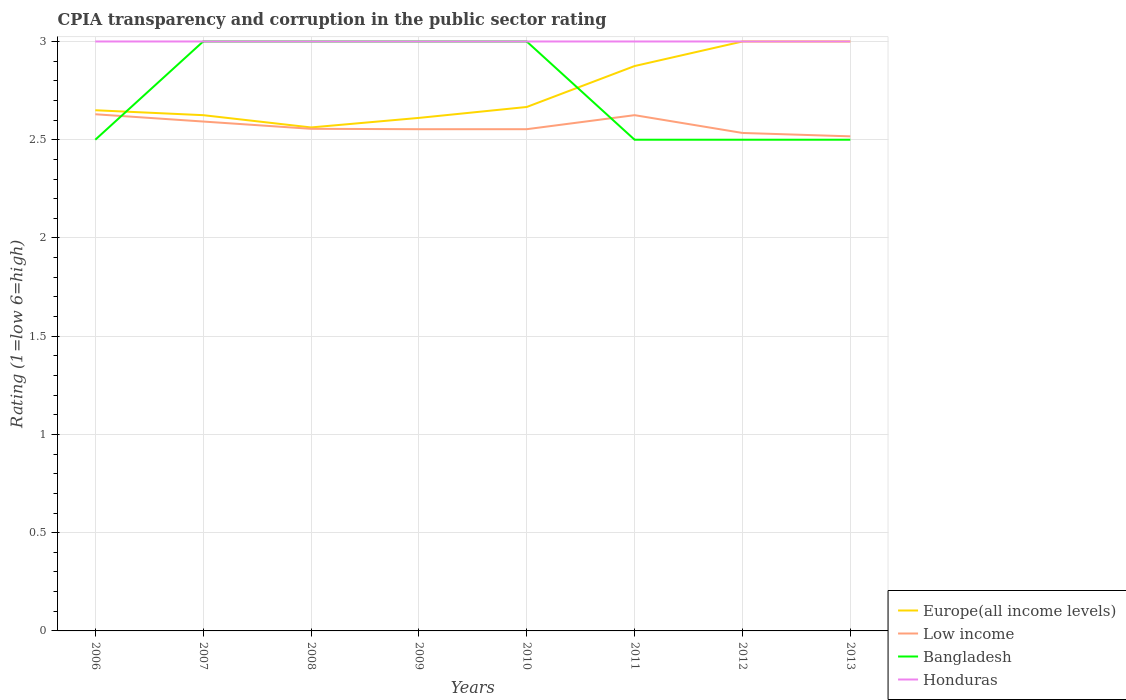How many different coloured lines are there?
Provide a succinct answer. 4. Is the number of lines equal to the number of legend labels?
Offer a terse response. Yes. Across all years, what is the maximum CPIA rating in Honduras?
Offer a terse response. 3. In which year was the CPIA rating in Low income maximum?
Give a very brief answer. 2013. What is the total CPIA rating in Bangladesh in the graph?
Ensure brevity in your answer.  0.5. What is the difference between the highest and the second highest CPIA rating in Low income?
Offer a very short reply. 0.11. What is the difference between the highest and the lowest CPIA rating in Bangladesh?
Offer a terse response. 4. Is the CPIA rating in Low income strictly greater than the CPIA rating in Honduras over the years?
Provide a short and direct response. Yes. How many years are there in the graph?
Ensure brevity in your answer.  8. What is the difference between two consecutive major ticks on the Y-axis?
Offer a terse response. 0.5. Does the graph contain any zero values?
Offer a terse response. No. Does the graph contain grids?
Make the answer very short. Yes. Where does the legend appear in the graph?
Your answer should be very brief. Bottom right. What is the title of the graph?
Your response must be concise. CPIA transparency and corruption in the public sector rating. Does "Uganda" appear as one of the legend labels in the graph?
Your answer should be compact. No. What is the Rating (1=low 6=high) in Europe(all income levels) in 2006?
Your response must be concise. 2.65. What is the Rating (1=low 6=high) of Low income in 2006?
Give a very brief answer. 2.63. What is the Rating (1=low 6=high) of Europe(all income levels) in 2007?
Ensure brevity in your answer.  2.62. What is the Rating (1=low 6=high) of Low income in 2007?
Your answer should be compact. 2.59. What is the Rating (1=low 6=high) in Bangladesh in 2007?
Make the answer very short. 3. What is the Rating (1=low 6=high) in Europe(all income levels) in 2008?
Ensure brevity in your answer.  2.56. What is the Rating (1=low 6=high) of Low income in 2008?
Keep it short and to the point. 2.56. What is the Rating (1=low 6=high) of Bangladesh in 2008?
Offer a very short reply. 3. What is the Rating (1=low 6=high) in Honduras in 2008?
Provide a succinct answer. 3. What is the Rating (1=low 6=high) in Europe(all income levels) in 2009?
Offer a terse response. 2.61. What is the Rating (1=low 6=high) of Low income in 2009?
Ensure brevity in your answer.  2.55. What is the Rating (1=low 6=high) in Bangladesh in 2009?
Ensure brevity in your answer.  3. What is the Rating (1=low 6=high) in Honduras in 2009?
Offer a very short reply. 3. What is the Rating (1=low 6=high) of Europe(all income levels) in 2010?
Your answer should be compact. 2.67. What is the Rating (1=low 6=high) of Low income in 2010?
Give a very brief answer. 2.55. What is the Rating (1=low 6=high) in Europe(all income levels) in 2011?
Ensure brevity in your answer.  2.88. What is the Rating (1=low 6=high) in Low income in 2011?
Give a very brief answer. 2.62. What is the Rating (1=low 6=high) in Bangladesh in 2011?
Your answer should be very brief. 2.5. What is the Rating (1=low 6=high) of Honduras in 2011?
Provide a short and direct response. 3. What is the Rating (1=low 6=high) of Europe(all income levels) in 2012?
Offer a very short reply. 3. What is the Rating (1=low 6=high) in Low income in 2012?
Keep it short and to the point. 2.53. What is the Rating (1=low 6=high) of Bangladesh in 2012?
Your response must be concise. 2.5. What is the Rating (1=low 6=high) of Europe(all income levels) in 2013?
Your response must be concise. 3. What is the Rating (1=low 6=high) of Low income in 2013?
Provide a short and direct response. 2.52. What is the Rating (1=low 6=high) in Honduras in 2013?
Offer a terse response. 3. Across all years, what is the maximum Rating (1=low 6=high) of Europe(all income levels)?
Offer a very short reply. 3. Across all years, what is the maximum Rating (1=low 6=high) of Low income?
Your response must be concise. 2.63. Across all years, what is the maximum Rating (1=low 6=high) in Honduras?
Offer a terse response. 3. Across all years, what is the minimum Rating (1=low 6=high) of Europe(all income levels)?
Keep it short and to the point. 2.56. Across all years, what is the minimum Rating (1=low 6=high) in Low income?
Give a very brief answer. 2.52. Across all years, what is the minimum Rating (1=low 6=high) in Bangladesh?
Offer a terse response. 2.5. What is the total Rating (1=low 6=high) of Europe(all income levels) in the graph?
Ensure brevity in your answer.  21.99. What is the total Rating (1=low 6=high) in Low income in the graph?
Keep it short and to the point. 20.56. What is the difference between the Rating (1=low 6=high) of Europe(all income levels) in 2006 and that in 2007?
Your response must be concise. 0.03. What is the difference between the Rating (1=low 6=high) in Low income in 2006 and that in 2007?
Offer a terse response. 0.04. What is the difference between the Rating (1=low 6=high) of Bangladesh in 2006 and that in 2007?
Make the answer very short. -0.5. What is the difference between the Rating (1=low 6=high) in Honduras in 2006 and that in 2007?
Keep it short and to the point. 0. What is the difference between the Rating (1=low 6=high) in Europe(all income levels) in 2006 and that in 2008?
Keep it short and to the point. 0.09. What is the difference between the Rating (1=low 6=high) in Low income in 2006 and that in 2008?
Your answer should be very brief. 0.07. What is the difference between the Rating (1=low 6=high) of Honduras in 2006 and that in 2008?
Make the answer very short. 0. What is the difference between the Rating (1=low 6=high) in Europe(all income levels) in 2006 and that in 2009?
Keep it short and to the point. 0.04. What is the difference between the Rating (1=low 6=high) in Low income in 2006 and that in 2009?
Make the answer very short. 0.08. What is the difference between the Rating (1=low 6=high) in Honduras in 2006 and that in 2009?
Provide a short and direct response. 0. What is the difference between the Rating (1=low 6=high) in Europe(all income levels) in 2006 and that in 2010?
Offer a terse response. -0.02. What is the difference between the Rating (1=low 6=high) of Low income in 2006 and that in 2010?
Offer a terse response. 0.08. What is the difference between the Rating (1=low 6=high) of Honduras in 2006 and that in 2010?
Provide a succinct answer. 0. What is the difference between the Rating (1=low 6=high) in Europe(all income levels) in 2006 and that in 2011?
Make the answer very short. -0.23. What is the difference between the Rating (1=low 6=high) in Low income in 2006 and that in 2011?
Provide a short and direct response. 0. What is the difference between the Rating (1=low 6=high) in Bangladesh in 2006 and that in 2011?
Give a very brief answer. 0. What is the difference between the Rating (1=low 6=high) of Europe(all income levels) in 2006 and that in 2012?
Give a very brief answer. -0.35. What is the difference between the Rating (1=low 6=high) of Low income in 2006 and that in 2012?
Provide a succinct answer. 0.1. What is the difference between the Rating (1=low 6=high) in Europe(all income levels) in 2006 and that in 2013?
Offer a very short reply. -0.35. What is the difference between the Rating (1=low 6=high) in Low income in 2006 and that in 2013?
Make the answer very short. 0.11. What is the difference between the Rating (1=low 6=high) in Bangladesh in 2006 and that in 2013?
Ensure brevity in your answer.  0. What is the difference between the Rating (1=low 6=high) of Europe(all income levels) in 2007 and that in 2008?
Ensure brevity in your answer.  0.06. What is the difference between the Rating (1=low 6=high) in Low income in 2007 and that in 2008?
Give a very brief answer. 0.04. What is the difference between the Rating (1=low 6=high) of Europe(all income levels) in 2007 and that in 2009?
Make the answer very short. 0.01. What is the difference between the Rating (1=low 6=high) of Low income in 2007 and that in 2009?
Offer a terse response. 0.04. What is the difference between the Rating (1=low 6=high) of Europe(all income levels) in 2007 and that in 2010?
Offer a terse response. -0.04. What is the difference between the Rating (1=low 6=high) in Low income in 2007 and that in 2010?
Your answer should be compact. 0.04. What is the difference between the Rating (1=low 6=high) in Bangladesh in 2007 and that in 2010?
Offer a terse response. 0. What is the difference between the Rating (1=low 6=high) in Europe(all income levels) in 2007 and that in 2011?
Ensure brevity in your answer.  -0.25. What is the difference between the Rating (1=low 6=high) of Low income in 2007 and that in 2011?
Your response must be concise. -0.03. What is the difference between the Rating (1=low 6=high) of Honduras in 2007 and that in 2011?
Provide a short and direct response. 0. What is the difference between the Rating (1=low 6=high) in Europe(all income levels) in 2007 and that in 2012?
Provide a succinct answer. -0.38. What is the difference between the Rating (1=low 6=high) of Low income in 2007 and that in 2012?
Make the answer very short. 0.06. What is the difference between the Rating (1=low 6=high) in Europe(all income levels) in 2007 and that in 2013?
Your response must be concise. -0.38. What is the difference between the Rating (1=low 6=high) in Low income in 2007 and that in 2013?
Offer a very short reply. 0.08. What is the difference between the Rating (1=low 6=high) of Honduras in 2007 and that in 2013?
Give a very brief answer. 0. What is the difference between the Rating (1=low 6=high) of Europe(all income levels) in 2008 and that in 2009?
Your answer should be very brief. -0.05. What is the difference between the Rating (1=low 6=high) of Low income in 2008 and that in 2009?
Your answer should be very brief. 0. What is the difference between the Rating (1=low 6=high) of Bangladesh in 2008 and that in 2009?
Your answer should be compact. 0. What is the difference between the Rating (1=low 6=high) in Europe(all income levels) in 2008 and that in 2010?
Your response must be concise. -0.1. What is the difference between the Rating (1=low 6=high) in Low income in 2008 and that in 2010?
Provide a short and direct response. 0. What is the difference between the Rating (1=low 6=high) in Honduras in 2008 and that in 2010?
Provide a succinct answer. 0. What is the difference between the Rating (1=low 6=high) in Europe(all income levels) in 2008 and that in 2011?
Offer a very short reply. -0.31. What is the difference between the Rating (1=low 6=high) of Low income in 2008 and that in 2011?
Offer a terse response. -0.07. What is the difference between the Rating (1=low 6=high) of Honduras in 2008 and that in 2011?
Your answer should be very brief. 0. What is the difference between the Rating (1=low 6=high) in Europe(all income levels) in 2008 and that in 2012?
Your response must be concise. -0.44. What is the difference between the Rating (1=low 6=high) of Low income in 2008 and that in 2012?
Your answer should be very brief. 0.02. What is the difference between the Rating (1=low 6=high) in Bangladesh in 2008 and that in 2012?
Keep it short and to the point. 0.5. What is the difference between the Rating (1=low 6=high) of Europe(all income levels) in 2008 and that in 2013?
Offer a terse response. -0.44. What is the difference between the Rating (1=low 6=high) of Low income in 2008 and that in 2013?
Your answer should be compact. 0.04. What is the difference between the Rating (1=low 6=high) of Bangladesh in 2008 and that in 2013?
Your answer should be very brief. 0.5. What is the difference between the Rating (1=low 6=high) of Honduras in 2008 and that in 2013?
Keep it short and to the point. 0. What is the difference between the Rating (1=low 6=high) of Europe(all income levels) in 2009 and that in 2010?
Provide a short and direct response. -0.06. What is the difference between the Rating (1=low 6=high) of Low income in 2009 and that in 2010?
Offer a terse response. 0. What is the difference between the Rating (1=low 6=high) in Bangladesh in 2009 and that in 2010?
Make the answer very short. 0. What is the difference between the Rating (1=low 6=high) of Europe(all income levels) in 2009 and that in 2011?
Your answer should be compact. -0.26. What is the difference between the Rating (1=low 6=high) of Low income in 2009 and that in 2011?
Offer a very short reply. -0.07. What is the difference between the Rating (1=low 6=high) of Honduras in 2009 and that in 2011?
Provide a short and direct response. 0. What is the difference between the Rating (1=low 6=high) of Europe(all income levels) in 2009 and that in 2012?
Your response must be concise. -0.39. What is the difference between the Rating (1=low 6=high) in Low income in 2009 and that in 2012?
Your answer should be compact. 0.02. What is the difference between the Rating (1=low 6=high) in Bangladesh in 2009 and that in 2012?
Provide a short and direct response. 0.5. What is the difference between the Rating (1=low 6=high) of Europe(all income levels) in 2009 and that in 2013?
Make the answer very short. -0.39. What is the difference between the Rating (1=low 6=high) in Low income in 2009 and that in 2013?
Offer a very short reply. 0.04. What is the difference between the Rating (1=low 6=high) in Bangladesh in 2009 and that in 2013?
Ensure brevity in your answer.  0.5. What is the difference between the Rating (1=low 6=high) in Europe(all income levels) in 2010 and that in 2011?
Make the answer very short. -0.21. What is the difference between the Rating (1=low 6=high) in Low income in 2010 and that in 2011?
Provide a succinct answer. -0.07. What is the difference between the Rating (1=low 6=high) of Honduras in 2010 and that in 2011?
Your response must be concise. 0. What is the difference between the Rating (1=low 6=high) in Europe(all income levels) in 2010 and that in 2012?
Ensure brevity in your answer.  -0.33. What is the difference between the Rating (1=low 6=high) in Low income in 2010 and that in 2012?
Your response must be concise. 0.02. What is the difference between the Rating (1=low 6=high) in Honduras in 2010 and that in 2012?
Ensure brevity in your answer.  0. What is the difference between the Rating (1=low 6=high) of Europe(all income levels) in 2010 and that in 2013?
Your answer should be compact. -0.33. What is the difference between the Rating (1=low 6=high) of Low income in 2010 and that in 2013?
Your answer should be compact. 0.04. What is the difference between the Rating (1=low 6=high) in Europe(all income levels) in 2011 and that in 2012?
Provide a short and direct response. -0.12. What is the difference between the Rating (1=low 6=high) in Low income in 2011 and that in 2012?
Keep it short and to the point. 0.09. What is the difference between the Rating (1=low 6=high) in Honduras in 2011 and that in 2012?
Make the answer very short. 0. What is the difference between the Rating (1=low 6=high) in Europe(all income levels) in 2011 and that in 2013?
Keep it short and to the point. -0.12. What is the difference between the Rating (1=low 6=high) of Low income in 2011 and that in 2013?
Your answer should be compact. 0.11. What is the difference between the Rating (1=low 6=high) of Bangladesh in 2011 and that in 2013?
Provide a short and direct response. 0. What is the difference between the Rating (1=low 6=high) of Low income in 2012 and that in 2013?
Keep it short and to the point. 0.02. What is the difference between the Rating (1=low 6=high) of Honduras in 2012 and that in 2013?
Your answer should be very brief. 0. What is the difference between the Rating (1=low 6=high) of Europe(all income levels) in 2006 and the Rating (1=low 6=high) of Low income in 2007?
Offer a very short reply. 0.06. What is the difference between the Rating (1=low 6=high) in Europe(all income levels) in 2006 and the Rating (1=low 6=high) in Bangladesh in 2007?
Offer a terse response. -0.35. What is the difference between the Rating (1=low 6=high) of Europe(all income levels) in 2006 and the Rating (1=low 6=high) of Honduras in 2007?
Your response must be concise. -0.35. What is the difference between the Rating (1=low 6=high) in Low income in 2006 and the Rating (1=low 6=high) in Bangladesh in 2007?
Provide a short and direct response. -0.37. What is the difference between the Rating (1=low 6=high) of Low income in 2006 and the Rating (1=low 6=high) of Honduras in 2007?
Make the answer very short. -0.37. What is the difference between the Rating (1=low 6=high) in Bangladesh in 2006 and the Rating (1=low 6=high) in Honduras in 2007?
Make the answer very short. -0.5. What is the difference between the Rating (1=low 6=high) in Europe(all income levels) in 2006 and the Rating (1=low 6=high) in Low income in 2008?
Provide a succinct answer. 0.09. What is the difference between the Rating (1=low 6=high) in Europe(all income levels) in 2006 and the Rating (1=low 6=high) in Bangladesh in 2008?
Give a very brief answer. -0.35. What is the difference between the Rating (1=low 6=high) of Europe(all income levels) in 2006 and the Rating (1=low 6=high) of Honduras in 2008?
Offer a terse response. -0.35. What is the difference between the Rating (1=low 6=high) of Low income in 2006 and the Rating (1=low 6=high) of Bangladesh in 2008?
Give a very brief answer. -0.37. What is the difference between the Rating (1=low 6=high) in Low income in 2006 and the Rating (1=low 6=high) in Honduras in 2008?
Offer a very short reply. -0.37. What is the difference between the Rating (1=low 6=high) in Bangladesh in 2006 and the Rating (1=low 6=high) in Honduras in 2008?
Offer a very short reply. -0.5. What is the difference between the Rating (1=low 6=high) of Europe(all income levels) in 2006 and the Rating (1=low 6=high) of Low income in 2009?
Offer a very short reply. 0.1. What is the difference between the Rating (1=low 6=high) in Europe(all income levels) in 2006 and the Rating (1=low 6=high) in Bangladesh in 2009?
Provide a succinct answer. -0.35. What is the difference between the Rating (1=low 6=high) of Europe(all income levels) in 2006 and the Rating (1=low 6=high) of Honduras in 2009?
Give a very brief answer. -0.35. What is the difference between the Rating (1=low 6=high) of Low income in 2006 and the Rating (1=low 6=high) of Bangladesh in 2009?
Keep it short and to the point. -0.37. What is the difference between the Rating (1=low 6=high) of Low income in 2006 and the Rating (1=low 6=high) of Honduras in 2009?
Keep it short and to the point. -0.37. What is the difference between the Rating (1=low 6=high) of Bangladesh in 2006 and the Rating (1=low 6=high) of Honduras in 2009?
Offer a very short reply. -0.5. What is the difference between the Rating (1=low 6=high) of Europe(all income levels) in 2006 and the Rating (1=low 6=high) of Low income in 2010?
Provide a succinct answer. 0.1. What is the difference between the Rating (1=low 6=high) in Europe(all income levels) in 2006 and the Rating (1=low 6=high) in Bangladesh in 2010?
Give a very brief answer. -0.35. What is the difference between the Rating (1=low 6=high) in Europe(all income levels) in 2006 and the Rating (1=low 6=high) in Honduras in 2010?
Provide a short and direct response. -0.35. What is the difference between the Rating (1=low 6=high) of Low income in 2006 and the Rating (1=low 6=high) of Bangladesh in 2010?
Give a very brief answer. -0.37. What is the difference between the Rating (1=low 6=high) in Low income in 2006 and the Rating (1=low 6=high) in Honduras in 2010?
Ensure brevity in your answer.  -0.37. What is the difference between the Rating (1=low 6=high) of Europe(all income levels) in 2006 and the Rating (1=low 6=high) of Low income in 2011?
Your answer should be compact. 0.03. What is the difference between the Rating (1=low 6=high) of Europe(all income levels) in 2006 and the Rating (1=low 6=high) of Bangladesh in 2011?
Make the answer very short. 0.15. What is the difference between the Rating (1=low 6=high) in Europe(all income levels) in 2006 and the Rating (1=low 6=high) in Honduras in 2011?
Give a very brief answer. -0.35. What is the difference between the Rating (1=low 6=high) in Low income in 2006 and the Rating (1=low 6=high) in Bangladesh in 2011?
Keep it short and to the point. 0.13. What is the difference between the Rating (1=low 6=high) of Low income in 2006 and the Rating (1=low 6=high) of Honduras in 2011?
Provide a succinct answer. -0.37. What is the difference between the Rating (1=low 6=high) in Bangladesh in 2006 and the Rating (1=low 6=high) in Honduras in 2011?
Offer a terse response. -0.5. What is the difference between the Rating (1=low 6=high) of Europe(all income levels) in 2006 and the Rating (1=low 6=high) of Low income in 2012?
Your answer should be compact. 0.12. What is the difference between the Rating (1=low 6=high) of Europe(all income levels) in 2006 and the Rating (1=low 6=high) of Honduras in 2012?
Make the answer very short. -0.35. What is the difference between the Rating (1=low 6=high) in Low income in 2006 and the Rating (1=low 6=high) in Bangladesh in 2012?
Your response must be concise. 0.13. What is the difference between the Rating (1=low 6=high) of Low income in 2006 and the Rating (1=low 6=high) of Honduras in 2012?
Offer a very short reply. -0.37. What is the difference between the Rating (1=low 6=high) of Europe(all income levels) in 2006 and the Rating (1=low 6=high) of Low income in 2013?
Make the answer very short. 0.13. What is the difference between the Rating (1=low 6=high) in Europe(all income levels) in 2006 and the Rating (1=low 6=high) in Honduras in 2013?
Keep it short and to the point. -0.35. What is the difference between the Rating (1=low 6=high) in Low income in 2006 and the Rating (1=low 6=high) in Bangladesh in 2013?
Your answer should be very brief. 0.13. What is the difference between the Rating (1=low 6=high) of Low income in 2006 and the Rating (1=low 6=high) of Honduras in 2013?
Provide a succinct answer. -0.37. What is the difference between the Rating (1=low 6=high) of Bangladesh in 2006 and the Rating (1=low 6=high) of Honduras in 2013?
Ensure brevity in your answer.  -0.5. What is the difference between the Rating (1=low 6=high) of Europe(all income levels) in 2007 and the Rating (1=low 6=high) of Low income in 2008?
Keep it short and to the point. 0.07. What is the difference between the Rating (1=low 6=high) of Europe(all income levels) in 2007 and the Rating (1=low 6=high) of Bangladesh in 2008?
Your answer should be very brief. -0.38. What is the difference between the Rating (1=low 6=high) of Europe(all income levels) in 2007 and the Rating (1=low 6=high) of Honduras in 2008?
Offer a very short reply. -0.38. What is the difference between the Rating (1=low 6=high) of Low income in 2007 and the Rating (1=low 6=high) of Bangladesh in 2008?
Your answer should be compact. -0.41. What is the difference between the Rating (1=low 6=high) in Low income in 2007 and the Rating (1=low 6=high) in Honduras in 2008?
Make the answer very short. -0.41. What is the difference between the Rating (1=low 6=high) in Europe(all income levels) in 2007 and the Rating (1=low 6=high) in Low income in 2009?
Offer a terse response. 0.07. What is the difference between the Rating (1=low 6=high) in Europe(all income levels) in 2007 and the Rating (1=low 6=high) in Bangladesh in 2009?
Make the answer very short. -0.38. What is the difference between the Rating (1=low 6=high) of Europe(all income levels) in 2007 and the Rating (1=low 6=high) of Honduras in 2009?
Your response must be concise. -0.38. What is the difference between the Rating (1=low 6=high) of Low income in 2007 and the Rating (1=low 6=high) of Bangladesh in 2009?
Your answer should be very brief. -0.41. What is the difference between the Rating (1=low 6=high) of Low income in 2007 and the Rating (1=low 6=high) of Honduras in 2009?
Provide a succinct answer. -0.41. What is the difference between the Rating (1=low 6=high) in Bangladesh in 2007 and the Rating (1=low 6=high) in Honduras in 2009?
Keep it short and to the point. 0. What is the difference between the Rating (1=low 6=high) of Europe(all income levels) in 2007 and the Rating (1=low 6=high) of Low income in 2010?
Make the answer very short. 0.07. What is the difference between the Rating (1=low 6=high) in Europe(all income levels) in 2007 and the Rating (1=low 6=high) in Bangladesh in 2010?
Offer a terse response. -0.38. What is the difference between the Rating (1=low 6=high) of Europe(all income levels) in 2007 and the Rating (1=low 6=high) of Honduras in 2010?
Keep it short and to the point. -0.38. What is the difference between the Rating (1=low 6=high) of Low income in 2007 and the Rating (1=low 6=high) of Bangladesh in 2010?
Ensure brevity in your answer.  -0.41. What is the difference between the Rating (1=low 6=high) in Low income in 2007 and the Rating (1=low 6=high) in Honduras in 2010?
Give a very brief answer. -0.41. What is the difference between the Rating (1=low 6=high) in Bangladesh in 2007 and the Rating (1=low 6=high) in Honduras in 2010?
Provide a short and direct response. 0. What is the difference between the Rating (1=low 6=high) of Europe(all income levels) in 2007 and the Rating (1=low 6=high) of Bangladesh in 2011?
Keep it short and to the point. 0.12. What is the difference between the Rating (1=low 6=high) in Europe(all income levels) in 2007 and the Rating (1=low 6=high) in Honduras in 2011?
Your response must be concise. -0.38. What is the difference between the Rating (1=low 6=high) in Low income in 2007 and the Rating (1=low 6=high) in Bangladesh in 2011?
Offer a very short reply. 0.09. What is the difference between the Rating (1=low 6=high) of Low income in 2007 and the Rating (1=low 6=high) of Honduras in 2011?
Keep it short and to the point. -0.41. What is the difference between the Rating (1=low 6=high) in Europe(all income levels) in 2007 and the Rating (1=low 6=high) in Low income in 2012?
Offer a terse response. 0.09. What is the difference between the Rating (1=low 6=high) of Europe(all income levels) in 2007 and the Rating (1=low 6=high) of Honduras in 2012?
Offer a terse response. -0.38. What is the difference between the Rating (1=low 6=high) in Low income in 2007 and the Rating (1=low 6=high) in Bangladesh in 2012?
Keep it short and to the point. 0.09. What is the difference between the Rating (1=low 6=high) in Low income in 2007 and the Rating (1=low 6=high) in Honduras in 2012?
Make the answer very short. -0.41. What is the difference between the Rating (1=low 6=high) in Europe(all income levels) in 2007 and the Rating (1=low 6=high) in Low income in 2013?
Offer a very short reply. 0.11. What is the difference between the Rating (1=low 6=high) in Europe(all income levels) in 2007 and the Rating (1=low 6=high) in Honduras in 2013?
Offer a terse response. -0.38. What is the difference between the Rating (1=low 6=high) in Low income in 2007 and the Rating (1=low 6=high) in Bangladesh in 2013?
Keep it short and to the point. 0.09. What is the difference between the Rating (1=low 6=high) in Low income in 2007 and the Rating (1=low 6=high) in Honduras in 2013?
Make the answer very short. -0.41. What is the difference between the Rating (1=low 6=high) in Bangladesh in 2007 and the Rating (1=low 6=high) in Honduras in 2013?
Provide a short and direct response. 0. What is the difference between the Rating (1=low 6=high) in Europe(all income levels) in 2008 and the Rating (1=low 6=high) in Low income in 2009?
Offer a terse response. 0.01. What is the difference between the Rating (1=low 6=high) of Europe(all income levels) in 2008 and the Rating (1=low 6=high) of Bangladesh in 2009?
Make the answer very short. -0.44. What is the difference between the Rating (1=low 6=high) of Europe(all income levels) in 2008 and the Rating (1=low 6=high) of Honduras in 2009?
Keep it short and to the point. -0.44. What is the difference between the Rating (1=low 6=high) of Low income in 2008 and the Rating (1=low 6=high) of Bangladesh in 2009?
Offer a very short reply. -0.44. What is the difference between the Rating (1=low 6=high) of Low income in 2008 and the Rating (1=low 6=high) of Honduras in 2009?
Keep it short and to the point. -0.44. What is the difference between the Rating (1=low 6=high) of Bangladesh in 2008 and the Rating (1=low 6=high) of Honduras in 2009?
Keep it short and to the point. 0. What is the difference between the Rating (1=low 6=high) in Europe(all income levels) in 2008 and the Rating (1=low 6=high) in Low income in 2010?
Your answer should be very brief. 0.01. What is the difference between the Rating (1=low 6=high) of Europe(all income levels) in 2008 and the Rating (1=low 6=high) of Bangladesh in 2010?
Keep it short and to the point. -0.44. What is the difference between the Rating (1=low 6=high) of Europe(all income levels) in 2008 and the Rating (1=low 6=high) of Honduras in 2010?
Give a very brief answer. -0.44. What is the difference between the Rating (1=low 6=high) of Low income in 2008 and the Rating (1=low 6=high) of Bangladesh in 2010?
Provide a succinct answer. -0.44. What is the difference between the Rating (1=low 6=high) of Low income in 2008 and the Rating (1=low 6=high) of Honduras in 2010?
Your answer should be compact. -0.44. What is the difference between the Rating (1=low 6=high) in Bangladesh in 2008 and the Rating (1=low 6=high) in Honduras in 2010?
Your response must be concise. 0. What is the difference between the Rating (1=low 6=high) of Europe(all income levels) in 2008 and the Rating (1=low 6=high) of Low income in 2011?
Keep it short and to the point. -0.06. What is the difference between the Rating (1=low 6=high) of Europe(all income levels) in 2008 and the Rating (1=low 6=high) of Bangladesh in 2011?
Keep it short and to the point. 0.06. What is the difference between the Rating (1=low 6=high) of Europe(all income levels) in 2008 and the Rating (1=low 6=high) of Honduras in 2011?
Offer a very short reply. -0.44. What is the difference between the Rating (1=low 6=high) in Low income in 2008 and the Rating (1=low 6=high) in Bangladesh in 2011?
Your answer should be compact. 0.06. What is the difference between the Rating (1=low 6=high) of Low income in 2008 and the Rating (1=low 6=high) of Honduras in 2011?
Your answer should be very brief. -0.44. What is the difference between the Rating (1=low 6=high) in Europe(all income levels) in 2008 and the Rating (1=low 6=high) in Low income in 2012?
Your answer should be compact. 0.03. What is the difference between the Rating (1=low 6=high) in Europe(all income levels) in 2008 and the Rating (1=low 6=high) in Bangladesh in 2012?
Offer a very short reply. 0.06. What is the difference between the Rating (1=low 6=high) in Europe(all income levels) in 2008 and the Rating (1=low 6=high) in Honduras in 2012?
Offer a very short reply. -0.44. What is the difference between the Rating (1=low 6=high) of Low income in 2008 and the Rating (1=low 6=high) of Bangladesh in 2012?
Make the answer very short. 0.06. What is the difference between the Rating (1=low 6=high) of Low income in 2008 and the Rating (1=low 6=high) of Honduras in 2012?
Your response must be concise. -0.44. What is the difference between the Rating (1=low 6=high) in Europe(all income levels) in 2008 and the Rating (1=low 6=high) in Low income in 2013?
Offer a very short reply. 0.05. What is the difference between the Rating (1=low 6=high) in Europe(all income levels) in 2008 and the Rating (1=low 6=high) in Bangladesh in 2013?
Your answer should be compact. 0.06. What is the difference between the Rating (1=low 6=high) in Europe(all income levels) in 2008 and the Rating (1=low 6=high) in Honduras in 2013?
Give a very brief answer. -0.44. What is the difference between the Rating (1=low 6=high) in Low income in 2008 and the Rating (1=low 6=high) in Bangladesh in 2013?
Give a very brief answer. 0.06. What is the difference between the Rating (1=low 6=high) in Low income in 2008 and the Rating (1=low 6=high) in Honduras in 2013?
Your answer should be very brief. -0.44. What is the difference between the Rating (1=low 6=high) in Europe(all income levels) in 2009 and the Rating (1=low 6=high) in Low income in 2010?
Ensure brevity in your answer.  0.06. What is the difference between the Rating (1=low 6=high) in Europe(all income levels) in 2009 and the Rating (1=low 6=high) in Bangladesh in 2010?
Keep it short and to the point. -0.39. What is the difference between the Rating (1=low 6=high) in Europe(all income levels) in 2009 and the Rating (1=low 6=high) in Honduras in 2010?
Provide a short and direct response. -0.39. What is the difference between the Rating (1=low 6=high) of Low income in 2009 and the Rating (1=low 6=high) of Bangladesh in 2010?
Provide a succinct answer. -0.45. What is the difference between the Rating (1=low 6=high) in Low income in 2009 and the Rating (1=low 6=high) in Honduras in 2010?
Provide a succinct answer. -0.45. What is the difference between the Rating (1=low 6=high) in Europe(all income levels) in 2009 and the Rating (1=low 6=high) in Low income in 2011?
Give a very brief answer. -0.01. What is the difference between the Rating (1=low 6=high) in Europe(all income levels) in 2009 and the Rating (1=low 6=high) in Bangladesh in 2011?
Provide a short and direct response. 0.11. What is the difference between the Rating (1=low 6=high) in Europe(all income levels) in 2009 and the Rating (1=low 6=high) in Honduras in 2011?
Provide a short and direct response. -0.39. What is the difference between the Rating (1=low 6=high) of Low income in 2009 and the Rating (1=low 6=high) of Bangladesh in 2011?
Your answer should be compact. 0.05. What is the difference between the Rating (1=low 6=high) of Low income in 2009 and the Rating (1=low 6=high) of Honduras in 2011?
Your response must be concise. -0.45. What is the difference between the Rating (1=low 6=high) of Europe(all income levels) in 2009 and the Rating (1=low 6=high) of Low income in 2012?
Provide a succinct answer. 0.08. What is the difference between the Rating (1=low 6=high) in Europe(all income levels) in 2009 and the Rating (1=low 6=high) in Honduras in 2012?
Keep it short and to the point. -0.39. What is the difference between the Rating (1=low 6=high) of Low income in 2009 and the Rating (1=low 6=high) of Bangladesh in 2012?
Your response must be concise. 0.05. What is the difference between the Rating (1=low 6=high) of Low income in 2009 and the Rating (1=low 6=high) of Honduras in 2012?
Make the answer very short. -0.45. What is the difference between the Rating (1=low 6=high) of Europe(all income levels) in 2009 and the Rating (1=low 6=high) of Low income in 2013?
Provide a short and direct response. 0.09. What is the difference between the Rating (1=low 6=high) of Europe(all income levels) in 2009 and the Rating (1=low 6=high) of Honduras in 2013?
Keep it short and to the point. -0.39. What is the difference between the Rating (1=low 6=high) of Low income in 2009 and the Rating (1=low 6=high) of Bangladesh in 2013?
Make the answer very short. 0.05. What is the difference between the Rating (1=low 6=high) of Low income in 2009 and the Rating (1=low 6=high) of Honduras in 2013?
Ensure brevity in your answer.  -0.45. What is the difference between the Rating (1=low 6=high) of Bangladesh in 2009 and the Rating (1=low 6=high) of Honduras in 2013?
Your answer should be compact. 0. What is the difference between the Rating (1=low 6=high) in Europe(all income levels) in 2010 and the Rating (1=low 6=high) in Low income in 2011?
Offer a very short reply. 0.04. What is the difference between the Rating (1=low 6=high) in Europe(all income levels) in 2010 and the Rating (1=low 6=high) in Bangladesh in 2011?
Give a very brief answer. 0.17. What is the difference between the Rating (1=low 6=high) in Low income in 2010 and the Rating (1=low 6=high) in Bangladesh in 2011?
Your answer should be compact. 0.05. What is the difference between the Rating (1=low 6=high) of Low income in 2010 and the Rating (1=low 6=high) of Honduras in 2011?
Offer a very short reply. -0.45. What is the difference between the Rating (1=low 6=high) of Bangladesh in 2010 and the Rating (1=low 6=high) of Honduras in 2011?
Make the answer very short. 0. What is the difference between the Rating (1=low 6=high) in Europe(all income levels) in 2010 and the Rating (1=low 6=high) in Low income in 2012?
Your response must be concise. 0.13. What is the difference between the Rating (1=low 6=high) in Europe(all income levels) in 2010 and the Rating (1=low 6=high) in Bangladesh in 2012?
Provide a short and direct response. 0.17. What is the difference between the Rating (1=low 6=high) in Low income in 2010 and the Rating (1=low 6=high) in Bangladesh in 2012?
Your answer should be compact. 0.05. What is the difference between the Rating (1=low 6=high) of Low income in 2010 and the Rating (1=low 6=high) of Honduras in 2012?
Give a very brief answer. -0.45. What is the difference between the Rating (1=low 6=high) in Europe(all income levels) in 2010 and the Rating (1=low 6=high) in Low income in 2013?
Provide a succinct answer. 0.15. What is the difference between the Rating (1=low 6=high) of Europe(all income levels) in 2010 and the Rating (1=low 6=high) of Bangladesh in 2013?
Make the answer very short. 0.17. What is the difference between the Rating (1=low 6=high) of Europe(all income levels) in 2010 and the Rating (1=low 6=high) of Honduras in 2013?
Provide a succinct answer. -0.33. What is the difference between the Rating (1=low 6=high) of Low income in 2010 and the Rating (1=low 6=high) of Bangladesh in 2013?
Make the answer very short. 0.05. What is the difference between the Rating (1=low 6=high) in Low income in 2010 and the Rating (1=low 6=high) in Honduras in 2013?
Make the answer very short. -0.45. What is the difference between the Rating (1=low 6=high) in Bangladesh in 2010 and the Rating (1=low 6=high) in Honduras in 2013?
Your answer should be compact. 0. What is the difference between the Rating (1=low 6=high) in Europe(all income levels) in 2011 and the Rating (1=low 6=high) in Low income in 2012?
Provide a succinct answer. 0.34. What is the difference between the Rating (1=low 6=high) in Europe(all income levels) in 2011 and the Rating (1=low 6=high) in Honduras in 2012?
Ensure brevity in your answer.  -0.12. What is the difference between the Rating (1=low 6=high) of Low income in 2011 and the Rating (1=low 6=high) of Honduras in 2012?
Your response must be concise. -0.38. What is the difference between the Rating (1=low 6=high) of Bangladesh in 2011 and the Rating (1=low 6=high) of Honduras in 2012?
Provide a succinct answer. -0.5. What is the difference between the Rating (1=low 6=high) of Europe(all income levels) in 2011 and the Rating (1=low 6=high) of Low income in 2013?
Your answer should be compact. 0.36. What is the difference between the Rating (1=low 6=high) of Europe(all income levels) in 2011 and the Rating (1=low 6=high) of Bangladesh in 2013?
Offer a very short reply. 0.38. What is the difference between the Rating (1=low 6=high) in Europe(all income levels) in 2011 and the Rating (1=low 6=high) in Honduras in 2013?
Offer a terse response. -0.12. What is the difference between the Rating (1=low 6=high) of Low income in 2011 and the Rating (1=low 6=high) of Honduras in 2013?
Ensure brevity in your answer.  -0.38. What is the difference between the Rating (1=low 6=high) of Europe(all income levels) in 2012 and the Rating (1=low 6=high) of Low income in 2013?
Your answer should be very brief. 0.48. What is the difference between the Rating (1=low 6=high) of Europe(all income levels) in 2012 and the Rating (1=low 6=high) of Bangladesh in 2013?
Ensure brevity in your answer.  0.5. What is the difference between the Rating (1=low 6=high) of Low income in 2012 and the Rating (1=low 6=high) of Bangladesh in 2013?
Your answer should be compact. 0.03. What is the difference between the Rating (1=low 6=high) of Low income in 2012 and the Rating (1=low 6=high) of Honduras in 2013?
Ensure brevity in your answer.  -0.47. What is the average Rating (1=low 6=high) in Europe(all income levels) per year?
Ensure brevity in your answer.  2.75. What is the average Rating (1=low 6=high) of Low income per year?
Your response must be concise. 2.57. What is the average Rating (1=low 6=high) in Bangladesh per year?
Provide a short and direct response. 2.75. In the year 2006, what is the difference between the Rating (1=low 6=high) in Europe(all income levels) and Rating (1=low 6=high) in Low income?
Provide a succinct answer. 0.02. In the year 2006, what is the difference between the Rating (1=low 6=high) in Europe(all income levels) and Rating (1=low 6=high) in Bangladesh?
Your answer should be compact. 0.15. In the year 2006, what is the difference between the Rating (1=low 6=high) in Europe(all income levels) and Rating (1=low 6=high) in Honduras?
Offer a terse response. -0.35. In the year 2006, what is the difference between the Rating (1=low 6=high) of Low income and Rating (1=low 6=high) of Bangladesh?
Give a very brief answer. 0.13. In the year 2006, what is the difference between the Rating (1=low 6=high) in Low income and Rating (1=low 6=high) in Honduras?
Make the answer very short. -0.37. In the year 2007, what is the difference between the Rating (1=low 6=high) in Europe(all income levels) and Rating (1=low 6=high) in Low income?
Offer a very short reply. 0.03. In the year 2007, what is the difference between the Rating (1=low 6=high) of Europe(all income levels) and Rating (1=low 6=high) of Bangladesh?
Give a very brief answer. -0.38. In the year 2007, what is the difference between the Rating (1=low 6=high) of Europe(all income levels) and Rating (1=low 6=high) of Honduras?
Offer a terse response. -0.38. In the year 2007, what is the difference between the Rating (1=low 6=high) in Low income and Rating (1=low 6=high) in Bangladesh?
Your response must be concise. -0.41. In the year 2007, what is the difference between the Rating (1=low 6=high) in Low income and Rating (1=low 6=high) in Honduras?
Your answer should be very brief. -0.41. In the year 2007, what is the difference between the Rating (1=low 6=high) in Bangladesh and Rating (1=low 6=high) in Honduras?
Keep it short and to the point. 0. In the year 2008, what is the difference between the Rating (1=low 6=high) in Europe(all income levels) and Rating (1=low 6=high) in Low income?
Your answer should be compact. 0.01. In the year 2008, what is the difference between the Rating (1=low 6=high) of Europe(all income levels) and Rating (1=low 6=high) of Bangladesh?
Your answer should be compact. -0.44. In the year 2008, what is the difference between the Rating (1=low 6=high) in Europe(all income levels) and Rating (1=low 6=high) in Honduras?
Your answer should be compact. -0.44. In the year 2008, what is the difference between the Rating (1=low 6=high) of Low income and Rating (1=low 6=high) of Bangladesh?
Provide a succinct answer. -0.44. In the year 2008, what is the difference between the Rating (1=low 6=high) in Low income and Rating (1=low 6=high) in Honduras?
Keep it short and to the point. -0.44. In the year 2008, what is the difference between the Rating (1=low 6=high) in Bangladesh and Rating (1=low 6=high) in Honduras?
Your response must be concise. 0. In the year 2009, what is the difference between the Rating (1=low 6=high) of Europe(all income levels) and Rating (1=low 6=high) of Low income?
Offer a terse response. 0.06. In the year 2009, what is the difference between the Rating (1=low 6=high) of Europe(all income levels) and Rating (1=low 6=high) of Bangladesh?
Your answer should be compact. -0.39. In the year 2009, what is the difference between the Rating (1=low 6=high) of Europe(all income levels) and Rating (1=low 6=high) of Honduras?
Keep it short and to the point. -0.39. In the year 2009, what is the difference between the Rating (1=low 6=high) in Low income and Rating (1=low 6=high) in Bangladesh?
Ensure brevity in your answer.  -0.45. In the year 2009, what is the difference between the Rating (1=low 6=high) in Low income and Rating (1=low 6=high) in Honduras?
Your answer should be compact. -0.45. In the year 2009, what is the difference between the Rating (1=low 6=high) of Bangladesh and Rating (1=low 6=high) of Honduras?
Give a very brief answer. 0. In the year 2010, what is the difference between the Rating (1=low 6=high) in Europe(all income levels) and Rating (1=low 6=high) in Low income?
Your response must be concise. 0.11. In the year 2010, what is the difference between the Rating (1=low 6=high) of Low income and Rating (1=low 6=high) of Bangladesh?
Your answer should be very brief. -0.45. In the year 2010, what is the difference between the Rating (1=low 6=high) of Low income and Rating (1=low 6=high) of Honduras?
Make the answer very short. -0.45. In the year 2010, what is the difference between the Rating (1=low 6=high) of Bangladesh and Rating (1=low 6=high) of Honduras?
Your answer should be compact. 0. In the year 2011, what is the difference between the Rating (1=low 6=high) of Europe(all income levels) and Rating (1=low 6=high) of Low income?
Make the answer very short. 0.25. In the year 2011, what is the difference between the Rating (1=low 6=high) of Europe(all income levels) and Rating (1=low 6=high) of Honduras?
Ensure brevity in your answer.  -0.12. In the year 2011, what is the difference between the Rating (1=low 6=high) of Low income and Rating (1=low 6=high) of Bangladesh?
Provide a short and direct response. 0.12. In the year 2011, what is the difference between the Rating (1=low 6=high) in Low income and Rating (1=low 6=high) in Honduras?
Keep it short and to the point. -0.38. In the year 2012, what is the difference between the Rating (1=low 6=high) of Europe(all income levels) and Rating (1=low 6=high) of Low income?
Keep it short and to the point. 0.47. In the year 2012, what is the difference between the Rating (1=low 6=high) in Low income and Rating (1=low 6=high) in Bangladesh?
Offer a very short reply. 0.03. In the year 2012, what is the difference between the Rating (1=low 6=high) of Low income and Rating (1=low 6=high) of Honduras?
Your answer should be compact. -0.47. In the year 2012, what is the difference between the Rating (1=low 6=high) of Bangladesh and Rating (1=low 6=high) of Honduras?
Offer a terse response. -0.5. In the year 2013, what is the difference between the Rating (1=low 6=high) of Europe(all income levels) and Rating (1=low 6=high) of Low income?
Give a very brief answer. 0.48. In the year 2013, what is the difference between the Rating (1=low 6=high) of Europe(all income levels) and Rating (1=low 6=high) of Honduras?
Give a very brief answer. 0. In the year 2013, what is the difference between the Rating (1=low 6=high) in Low income and Rating (1=low 6=high) in Bangladesh?
Make the answer very short. 0.02. In the year 2013, what is the difference between the Rating (1=low 6=high) of Low income and Rating (1=low 6=high) of Honduras?
Provide a succinct answer. -0.48. In the year 2013, what is the difference between the Rating (1=low 6=high) of Bangladesh and Rating (1=low 6=high) of Honduras?
Offer a very short reply. -0.5. What is the ratio of the Rating (1=low 6=high) of Europe(all income levels) in 2006 to that in 2007?
Offer a terse response. 1.01. What is the ratio of the Rating (1=low 6=high) in Low income in 2006 to that in 2007?
Give a very brief answer. 1.01. What is the ratio of the Rating (1=low 6=high) in Bangladesh in 2006 to that in 2007?
Your answer should be very brief. 0.83. What is the ratio of the Rating (1=low 6=high) in Honduras in 2006 to that in 2007?
Make the answer very short. 1. What is the ratio of the Rating (1=low 6=high) of Europe(all income levels) in 2006 to that in 2008?
Keep it short and to the point. 1.03. What is the ratio of the Rating (1=low 6=high) of Bangladesh in 2006 to that in 2008?
Offer a terse response. 0.83. What is the ratio of the Rating (1=low 6=high) of Europe(all income levels) in 2006 to that in 2009?
Keep it short and to the point. 1.01. What is the ratio of the Rating (1=low 6=high) of Low income in 2006 to that in 2009?
Offer a very short reply. 1.03. What is the ratio of the Rating (1=low 6=high) in Bangladesh in 2006 to that in 2009?
Ensure brevity in your answer.  0.83. What is the ratio of the Rating (1=low 6=high) of Low income in 2006 to that in 2010?
Make the answer very short. 1.03. What is the ratio of the Rating (1=low 6=high) of Bangladesh in 2006 to that in 2010?
Provide a succinct answer. 0.83. What is the ratio of the Rating (1=low 6=high) in Honduras in 2006 to that in 2010?
Keep it short and to the point. 1. What is the ratio of the Rating (1=low 6=high) of Europe(all income levels) in 2006 to that in 2011?
Your answer should be compact. 0.92. What is the ratio of the Rating (1=low 6=high) of Bangladesh in 2006 to that in 2011?
Make the answer very short. 1. What is the ratio of the Rating (1=low 6=high) in Europe(all income levels) in 2006 to that in 2012?
Make the answer very short. 0.88. What is the ratio of the Rating (1=low 6=high) in Low income in 2006 to that in 2012?
Keep it short and to the point. 1.04. What is the ratio of the Rating (1=low 6=high) of Bangladesh in 2006 to that in 2012?
Keep it short and to the point. 1. What is the ratio of the Rating (1=low 6=high) in Europe(all income levels) in 2006 to that in 2013?
Give a very brief answer. 0.88. What is the ratio of the Rating (1=low 6=high) of Low income in 2006 to that in 2013?
Your answer should be compact. 1.04. What is the ratio of the Rating (1=low 6=high) of Europe(all income levels) in 2007 to that in 2008?
Ensure brevity in your answer.  1.02. What is the ratio of the Rating (1=low 6=high) in Low income in 2007 to that in 2008?
Provide a succinct answer. 1.01. What is the ratio of the Rating (1=low 6=high) in Honduras in 2007 to that in 2008?
Your response must be concise. 1. What is the ratio of the Rating (1=low 6=high) in Europe(all income levels) in 2007 to that in 2009?
Offer a very short reply. 1.01. What is the ratio of the Rating (1=low 6=high) of Low income in 2007 to that in 2009?
Offer a terse response. 1.02. What is the ratio of the Rating (1=low 6=high) of Bangladesh in 2007 to that in 2009?
Your answer should be very brief. 1. What is the ratio of the Rating (1=low 6=high) of Honduras in 2007 to that in 2009?
Provide a succinct answer. 1. What is the ratio of the Rating (1=low 6=high) of Europe(all income levels) in 2007 to that in 2010?
Keep it short and to the point. 0.98. What is the ratio of the Rating (1=low 6=high) in Low income in 2007 to that in 2010?
Keep it short and to the point. 1.02. What is the ratio of the Rating (1=low 6=high) of Bangladesh in 2007 to that in 2010?
Keep it short and to the point. 1. What is the ratio of the Rating (1=low 6=high) of Low income in 2007 to that in 2011?
Offer a very short reply. 0.99. What is the ratio of the Rating (1=low 6=high) in Europe(all income levels) in 2007 to that in 2012?
Offer a very short reply. 0.88. What is the ratio of the Rating (1=low 6=high) in Low income in 2007 to that in 2012?
Make the answer very short. 1.02. What is the ratio of the Rating (1=low 6=high) in Bangladesh in 2007 to that in 2012?
Keep it short and to the point. 1.2. What is the ratio of the Rating (1=low 6=high) of Low income in 2007 to that in 2013?
Offer a terse response. 1.03. What is the ratio of the Rating (1=low 6=high) of Bangladesh in 2007 to that in 2013?
Your answer should be compact. 1.2. What is the ratio of the Rating (1=low 6=high) in Europe(all income levels) in 2008 to that in 2009?
Keep it short and to the point. 0.98. What is the ratio of the Rating (1=low 6=high) in Honduras in 2008 to that in 2009?
Provide a succinct answer. 1. What is the ratio of the Rating (1=low 6=high) in Europe(all income levels) in 2008 to that in 2010?
Your answer should be compact. 0.96. What is the ratio of the Rating (1=low 6=high) of Bangladesh in 2008 to that in 2010?
Your answer should be very brief. 1. What is the ratio of the Rating (1=low 6=high) of Honduras in 2008 to that in 2010?
Your answer should be very brief. 1. What is the ratio of the Rating (1=low 6=high) of Europe(all income levels) in 2008 to that in 2011?
Your answer should be very brief. 0.89. What is the ratio of the Rating (1=low 6=high) of Low income in 2008 to that in 2011?
Ensure brevity in your answer.  0.97. What is the ratio of the Rating (1=low 6=high) of Europe(all income levels) in 2008 to that in 2012?
Offer a very short reply. 0.85. What is the ratio of the Rating (1=low 6=high) in Low income in 2008 to that in 2012?
Your answer should be compact. 1.01. What is the ratio of the Rating (1=low 6=high) of Europe(all income levels) in 2008 to that in 2013?
Offer a terse response. 0.85. What is the ratio of the Rating (1=low 6=high) of Low income in 2008 to that in 2013?
Ensure brevity in your answer.  1.02. What is the ratio of the Rating (1=low 6=high) in Bangladesh in 2008 to that in 2013?
Make the answer very short. 1.2. What is the ratio of the Rating (1=low 6=high) in Europe(all income levels) in 2009 to that in 2010?
Provide a short and direct response. 0.98. What is the ratio of the Rating (1=low 6=high) of Bangladesh in 2009 to that in 2010?
Your answer should be compact. 1. What is the ratio of the Rating (1=low 6=high) of Honduras in 2009 to that in 2010?
Your response must be concise. 1. What is the ratio of the Rating (1=low 6=high) of Europe(all income levels) in 2009 to that in 2011?
Offer a terse response. 0.91. What is the ratio of the Rating (1=low 6=high) of Low income in 2009 to that in 2011?
Offer a very short reply. 0.97. What is the ratio of the Rating (1=low 6=high) of Europe(all income levels) in 2009 to that in 2012?
Keep it short and to the point. 0.87. What is the ratio of the Rating (1=low 6=high) in Low income in 2009 to that in 2012?
Make the answer very short. 1.01. What is the ratio of the Rating (1=low 6=high) of Bangladesh in 2009 to that in 2012?
Ensure brevity in your answer.  1.2. What is the ratio of the Rating (1=low 6=high) of Europe(all income levels) in 2009 to that in 2013?
Provide a succinct answer. 0.87. What is the ratio of the Rating (1=low 6=high) of Low income in 2009 to that in 2013?
Offer a very short reply. 1.01. What is the ratio of the Rating (1=low 6=high) in Bangladesh in 2009 to that in 2013?
Offer a very short reply. 1.2. What is the ratio of the Rating (1=low 6=high) in Honduras in 2009 to that in 2013?
Provide a succinct answer. 1. What is the ratio of the Rating (1=low 6=high) in Europe(all income levels) in 2010 to that in 2011?
Your answer should be very brief. 0.93. What is the ratio of the Rating (1=low 6=high) of Low income in 2010 to that in 2011?
Your answer should be very brief. 0.97. What is the ratio of the Rating (1=low 6=high) of Bangladesh in 2010 to that in 2011?
Provide a short and direct response. 1.2. What is the ratio of the Rating (1=low 6=high) in Low income in 2010 to that in 2012?
Your answer should be compact. 1.01. What is the ratio of the Rating (1=low 6=high) in Bangladesh in 2010 to that in 2012?
Give a very brief answer. 1.2. What is the ratio of the Rating (1=low 6=high) in Europe(all income levels) in 2010 to that in 2013?
Make the answer very short. 0.89. What is the ratio of the Rating (1=low 6=high) in Low income in 2010 to that in 2013?
Keep it short and to the point. 1.01. What is the ratio of the Rating (1=low 6=high) of Europe(all income levels) in 2011 to that in 2012?
Your response must be concise. 0.96. What is the ratio of the Rating (1=low 6=high) of Low income in 2011 to that in 2012?
Offer a very short reply. 1.04. What is the ratio of the Rating (1=low 6=high) of Europe(all income levels) in 2011 to that in 2013?
Make the answer very short. 0.96. What is the ratio of the Rating (1=low 6=high) of Low income in 2011 to that in 2013?
Offer a terse response. 1.04. What is the ratio of the Rating (1=low 6=high) in Honduras in 2011 to that in 2013?
Your answer should be compact. 1. What is the ratio of the Rating (1=low 6=high) in Low income in 2012 to that in 2013?
Make the answer very short. 1.01. What is the ratio of the Rating (1=low 6=high) in Bangladesh in 2012 to that in 2013?
Ensure brevity in your answer.  1. What is the difference between the highest and the second highest Rating (1=low 6=high) of Low income?
Your answer should be compact. 0. What is the difference between the highest and the second highest Rating (1=low 6=high) of Honduras?
Provide a short and direct response. 0. What is the difference between the highest and the lowest Rating (1=low 6=high) in Europe(all income levels)?
Keep it short and to the point. 0.44. What is the difference between the highest and the lowest Rating (1=low 6=high) of Low income?
Offer a terse response. 0.11. What is the difference between the highest and the lowest Rating (1=low 6=high) in Bangladesh?
Offer a terse response. 0.5. 